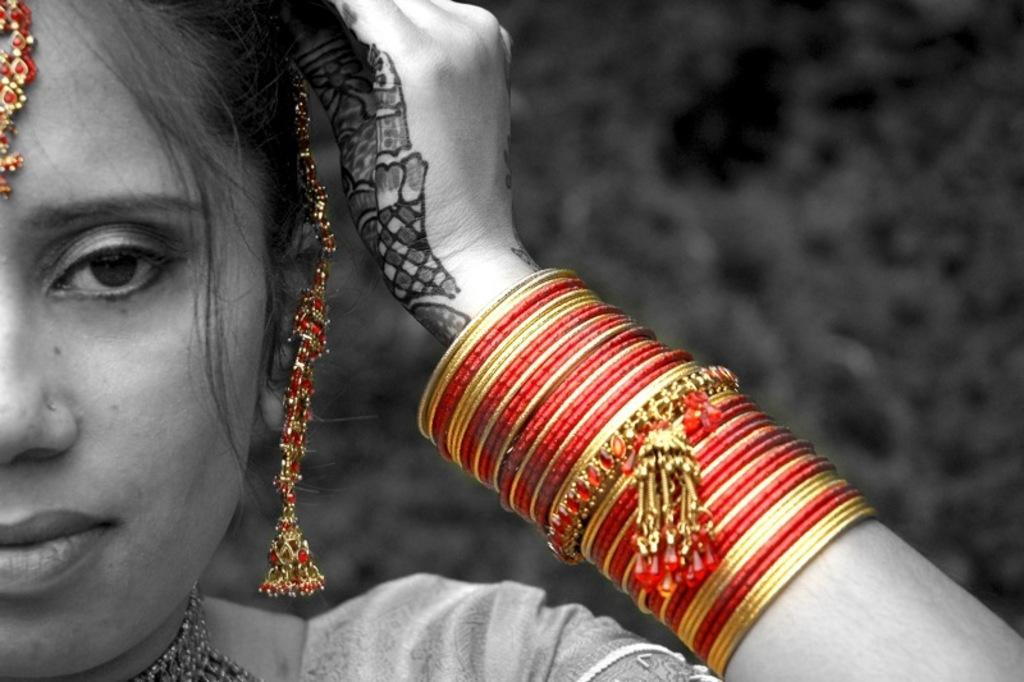How would you summarize this image in a sentence or two? In this image I can see a woman in the front and I can see she is wearing number of bangles and few jewelries. 